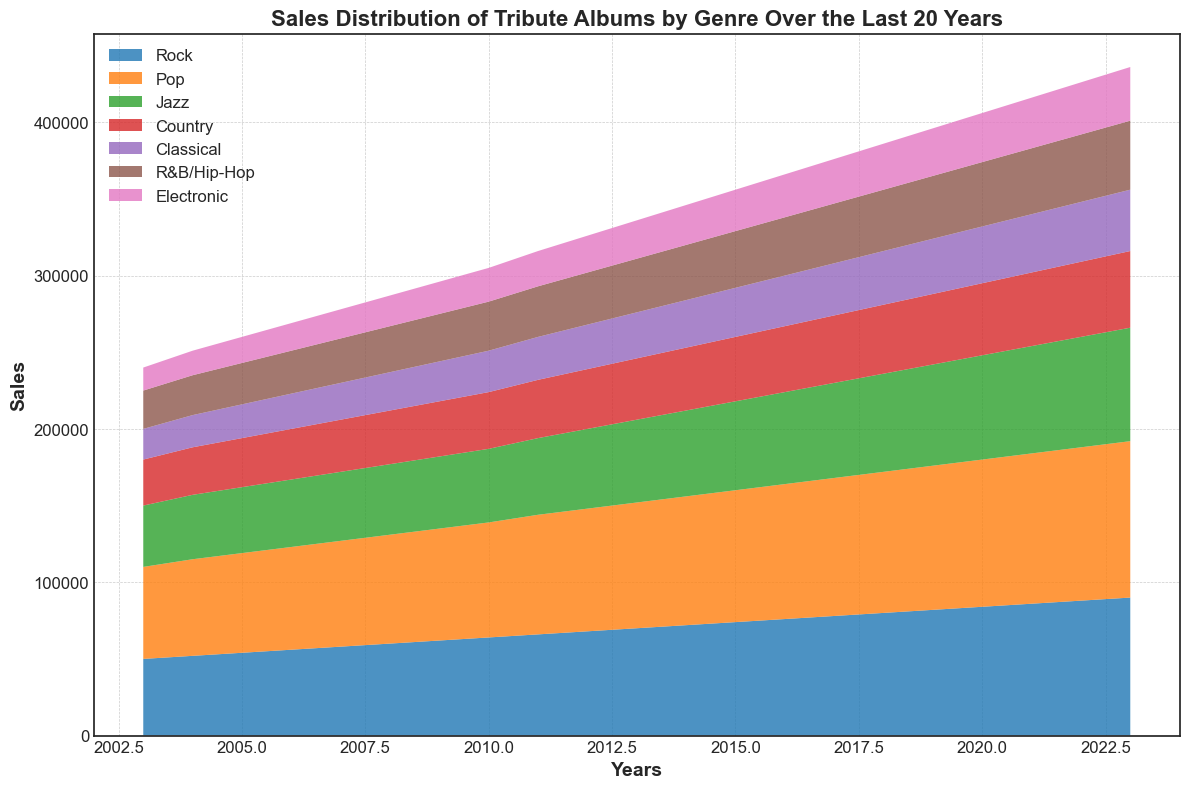Which genre showed the highest sales in 2023? The figure indicates sales for each genre over the years, with each genre represented by a distinct color. In 2023, the color area representing Pop is the highest, signifying that Pop had the highest sales.
Answer: Pop Which genre had steady growth without any dips in sales over the 20 years? By examining all the area sections, you can see the consistent increases without dips. All genres appear to be growing steadily without dips, but Classical shows this most clearly.
Answer: Classical How did the sales of Jazz in 2010 compare to the sales of Country in the same year? Locate the year 2010 on the x-axis and compare the heights of Jazz and Country. Jazz reaches 48,000 while Country reaches 37,000.
Answer: Jazz had higher sales than Country in 2010 by 11,000 Which genre saw the fastest increase in sales between 2010 and 2020? Examine the steepness of the area’s slope for each genre between 2010 and 2020. Pop’s area shows the steepest increase, indicating the fastest growth in sales.
Answer: Pop What is the combined sales figure for Rock and R&B/Hip-Hop in 2020? Find the 2020 sales for Rock (84,000) and R&B/Hip-Hop (42,000) then add together. 84,000 + 42,000
Answer: 126,000 Which genres have had overlapping areas that might make it difficult to distinguish their individual trends? Analyzing the chart, Electronic and R&B/Hip-Hop areas are close and could overlap at certain points, making distinction challenging.
Answer: Electronic and R&B/Hip-Hop Which genre experienced the smallest numerical increase in sales from 2003 to 2023? Calculate the increase for each genre by subtracting 2003 values from 2023. Identify the smallest increase, which is for R&B/Hip-Hop: 45,000 - 25,000 = 20,000.
Answer: R&B/Hip-Hop What was the approximate sales growth rate for Jazz between 2005 and 2010? Find 2005 (43,000) and 2010 (48,000) sales, then use the formula (new - old )/ old to find growth rate: (48,000 - 43,000) / 43,000 ≈ 0.116 or 11.6%.
Answer: 11.6% During which years did Pop have a higher sales increase than Rock? Assess the yearly changes for Pop and Rock. One obvious period is from 2011 to 2013 with evident steeper increase for Pop.
Answer: 2011-2013 Is the sales trend of Electronic significantly different from the trend of Classical over the years? Visually compare both trends over the years. While both show increases, Electronic starts lower and remains lower but follows a similar growth pattern like Classical.
Answer: No 